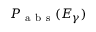<formula> <loc_0><loc_0><loc_500><loc_500>P _ { a b s } ( E _ { \gamma } )</formula> 